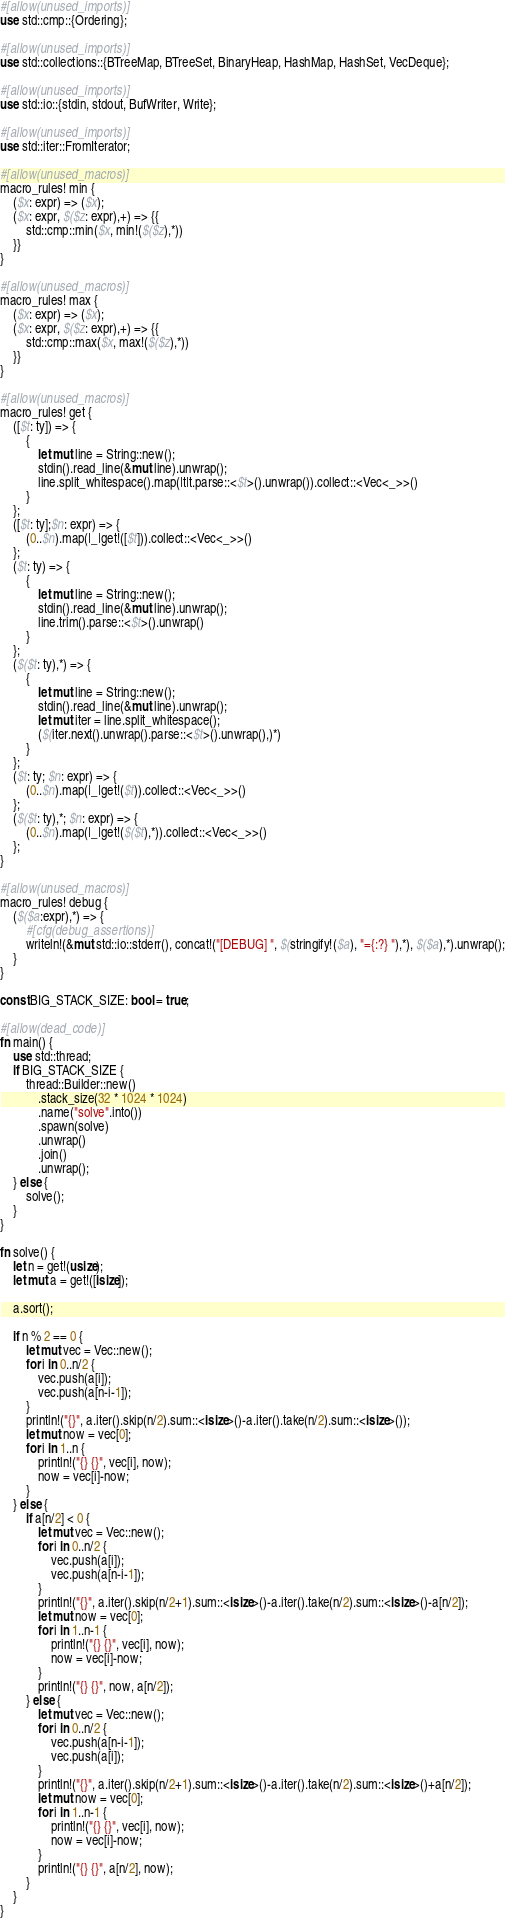<code> <loc_0><loc_0><loc_500><loc_500><_Rust_>#[allow(unused_imports)]
use std::cmp::{Ordering};

#[allow(unused_imports)]
use std::collections::{BTreeMap, BTreeSet, BinaryHeap, HashMap, HashSet, VecDeque};

#[allow(unused_imports)]
use std::io::{stdin, stdout, BufWriter, Write};

#[allow(unused_imports)]
use std::iter::FromIterator;

#[allow(unused_macros)]
macro_rules! min {
    ($x: expr) => ($x);
    ($x: expr, $($z: expr),+) => {{
        std::cmp::min($x, min!($($z),*))
    }}
}

#[allow(unused_macros)]
macro_rules! max {
    ($x: expr) => ($x);
    ($x: expr, $($z: expr),+) => {{
        std::cmp::max($x, max!($($z),*))
    }}
}

#[allow(unused_macros)]
macro_rules! get { 
    ([$t: ty]) => { 
        { 
            let mut line = String::new(); 
            stdin().read_line(&mut line).unwrap(); 
            line.split_whitespace().map(|t|t.parse::<$t>().unwrap()).collect::<Vec<_>>()
        }
    };
    ([$t: ty];$n: expr) => {
        (0..$n).map(|_|get!([$t])).collect::<Vec<_>>()
    };
    ($t: ty) => {
        {
            let mut line = String::new();
            stdin().read_line(&mut line).unwrap();
            line.trim().parse::<$t>().unwrap()
        }
    };
    ($($t: ty),*) => {
        { 
            let mut line = String::new();
            stdin().read_line(&mut line).unwrap();
            let mut iter = line.split_whitespace();
            ($(iter.next().unwrap().parse::<$t>().unwrap(),)*)
        }
    };
    ($t: ty; $n: expr) => {
        (0..$n).map(|_|get!($t)).collect::<Vec<_>>()
    };
    ($($t: ty),*; $n: expr) => {
        (0..$n).map(|_|get!($($t),*)).collect::<Vec<_>>()
    };
}

#[allow(unused_macros)]
macro_rules! debug {
    ($($a:expr),*) => {
        #[cfg(debug_assertions)]
        writeln!(&mut std::io::stderr(), concat!("[DEBUG] ", $(stringify!($a), "={:?} "),*), $($a),*).unwrap();
    }
}

const BIG_STACK_SIZE: bool = true;

#[allow(dead_code)]
fn main() {
    use std::thread;
    if BIG_STACK_SIZE {
        thread::Builder::new()
            .stack_size(32 * 1024 * 1024)
            .name("solve".into())
            .spawn(solve)
            .unwrap()
            .join()
            .unwrap();
    } else {
        solve();
    }
}

fn solve() {
    let n = get!(usize);
    let mut a = get!([isize]);

    a.sort();

    if n % 2 == 0 {
        let mut vec = Vec::new();
        for i in 0..n/2 {
            vec.push(a[i]);
            vec.push(a[n-i-1]);
        }
        println!("{}", a.iter().skip(n/2).sum::<isize>()-a.iter().take(n/2).sum::<isize>());
        let mut now = vec[0];
        for i in 1..n {
            println!("{} {}", vec[i], now);
            now = vec[i]-now;
        }
    } else {
        if a[n/2] < 0 {
            let mut vec = Vec::new();
            for i in 0..n/2 {
                vec.push(a[i]);
                vec.push(a[n-i-1]);
            }
            println!("{}", a.iter().skip(n/2+1).sum::<isize>()-a.iter().take(n/2).sum::<isize>()-a[n/2]);
            let mut now = vec[0];
            for i in 1..n-1 {
                println!("{} {}", vec[i], now);
                now = vec[i]-now;
            }
            println!("{} {}", now, a[n/2]); 
        } else {
            let mut vec = Vec::new();
            for i in 0..n/2 {
                vec.push(a[n-i-1]);
                vec.push(a[i]);
            }
            println!("{}", a.iter().skip(n/2+1).sum::<isize>()-a.iter().take(n/2).sum::<isize>()+a[n/2]);
            let mut now = vec[0];
            for i in 1..n-1 {
                println!("{} {}", vec[i], now);
                now = vec[i]-now;
            }
            println!("{} {}", a[n/2], now);
        }
    }
}
</code> 